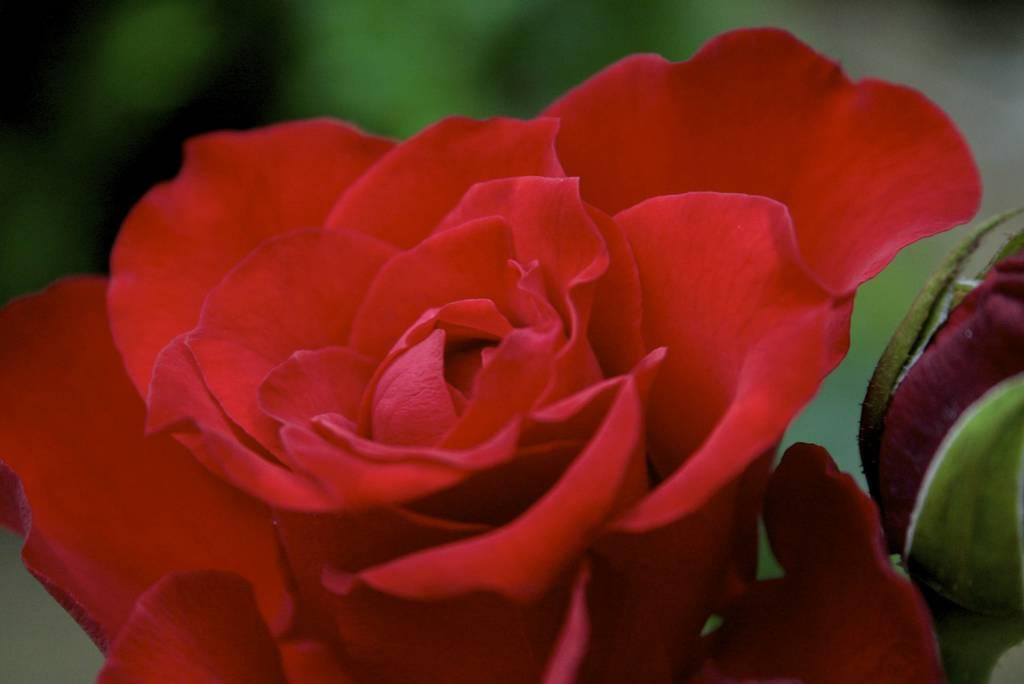What type of flower is in the picture? There is a red flower in the picture. Can you describe any specific features of the flower? There is a bud on the right side of the flower. What can be observed about the background of the image? The background of the image is blurred. What type of stamp is visible on the back of the flower? There is no stamp present on the flower, and the term "back" does not apply to a flower. 